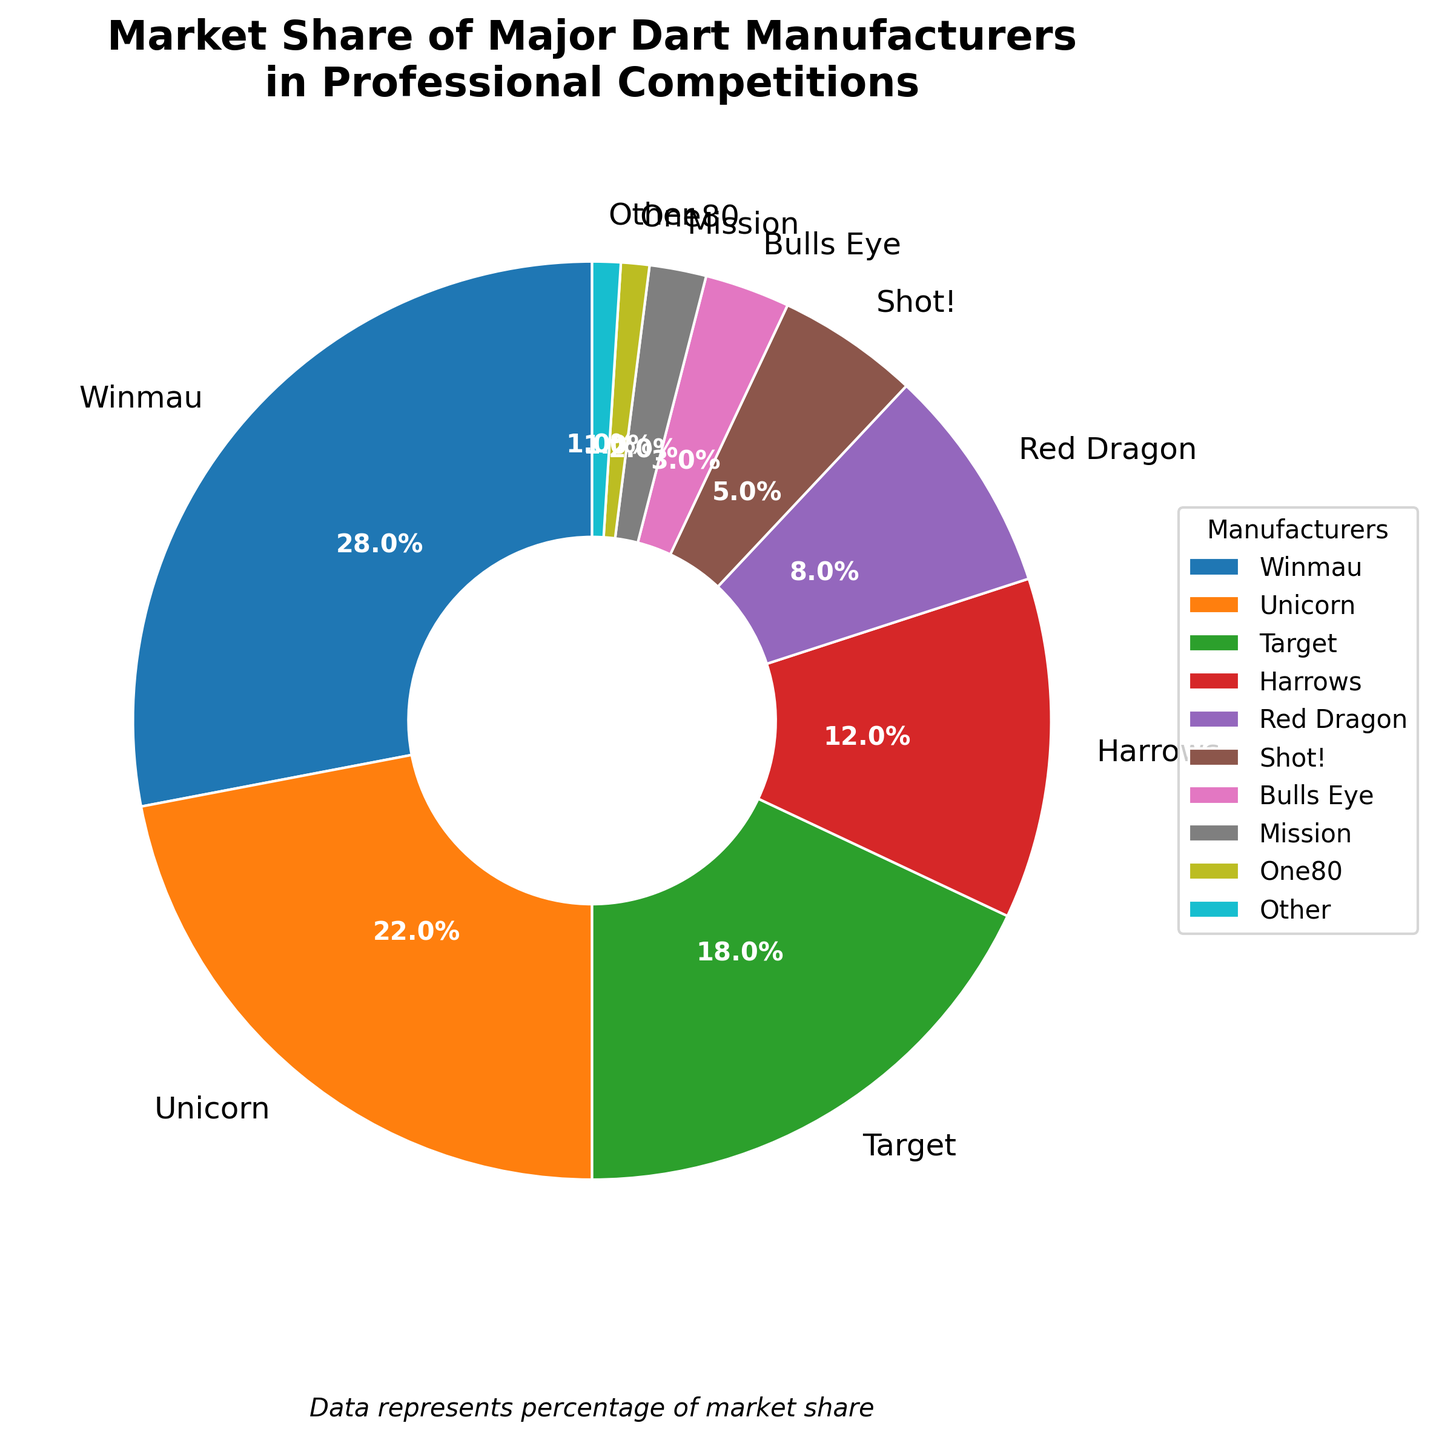Which manufacturer has the largest market share? The pie chart shows various segments representing different manufacturers. Winmau has the largest segment, indicating it has the largest market share.
Answer: Winmau Which manufacturer has a smaller market share, Shot! or Red Dragon? By comparing the segment sizes, Red Dragon's segment is larger than Shot!'s segment. Therefore, Shot! has a smaller market share.
Answer: Shot! What is the combined market share of Winmau and Unicorn? Winmau has a market share of 28%, and Unicorn has a market share of 22%. Summing them up gives 28% + 22% = 50%.
Answer: 50% How many manufacturers have a market share of 10% or more? Looking at the segments and their corresponding labels, Winmau, Unicorn, Target, and Harrows each have market shares of 10% or more. That's four manufacturers.
Answer: 4 Is the market share of Harrows greater than half of Unicorn's market share? Harrows has a market share of 12%, and Unicorn has a market share of 22%. Half of Unicorn's share is 22% / 2 = 11%. Since 12% > 11%, Harrows' market share is indeed greater than half of Unicorn's.
Answer: Yes What is the total market share of manufacturers with under 5% market share each? According to the chart, Shot!, Bulls Eye, Mission, One80, and Other have market shares of 5%, 3%, 2%, 1%, and 1% respectively. Summing them up gives 5% + 3% + 2% + 1% + 1% = 12%.
Answer: 12% Which segment color represents Red Dragon on the pie chart? By examining the chart's color legend and segment labels, Red Dragon is represented by one distinct color. The segment for Red Dragon appears in purple.
Answer: Purple (or the specific color if more detail is needed) If Unicorn's market share increased by 6%, what would this new market share be? Unicorn currently has a market share of 22%. Increasing it by 6% results in 22% + 6% = 28%.
Answer: 28% How does the market share of Target compare to the total market share of manufacturers with less than 5% each? Target has a market share of 18%. The combined market share of manufacturers with under 5% each is 12%. Comparing 18% to 12%, Target's market share is larger.
Answer: Larger 